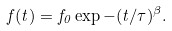<formula> <loc_0><loc_0><loc_500><loc_500>f ( t ) = f _ { 0 } \exp - ( t / \tau ) ^ { \beta } .</formula> 